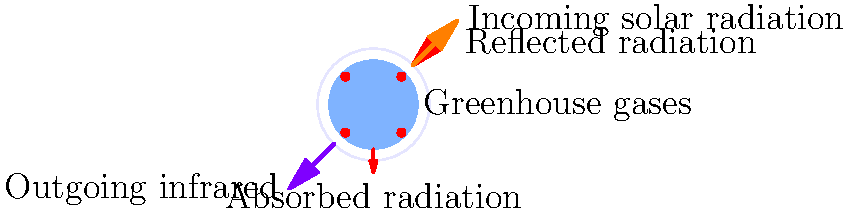As a politician advocating for climate change mitigation, you're presenting the greenhouse effect to your constituents. Using the diagram, explain how greenhouse gases contribute to global warming and why reducing emissions is crucial for preventing long-term environmental and economic impacts. 1. Solar radiation: The sun emits shortwave radiation that passes through the atmosphere and reaches Earth's surface.

2. Absorption and reflection: Some of this radiation is reflected back into space by clouds and Earth's surface, while the rest is absorbed by the planet.

3. Earth's emission: The absorbed energy warms the Earth, which then emits longwave infrared radiation back towards space.

4. Greenhouse gases: CO₂, methane, and other greenhouse gases in the atmosphere absorb some of this outgoing infrared radiation.

5. Heat trapping: These gases re-emit the absorbed energy in all directions, including back towards Earth's surface, effectively trapping heat in the lower atmosphere.

6. Enhanced greenhouse effect: As we increase greenhouse gas concentrations through human activities, more heat is trapped, leading to global warming.

7. Climate impacts: This warming causes various environmental changes, including sea-level rise, extreme weather events, and ecosystem disruptions.

8. Economic consequences: These changes can lead to significant economic impacts, affecting agriculture, infrastructure, and public health.

9. Mitigation importance: Reducing greenhouse gas emissions is crucial to slow down this process and minimize long-term environmental and economic damage.

10. Policy implications: As policymakers, we must implement strategies to reduce emissions, such as promoting renewable energy, improving energy efficiency, and supporting sustainable practices across industries.
Answer: Greenhouse gases trap outgoing infrared radiation, causing global warming. Reducing emissions is crucial to mitigate long-term environmental and economic impacts. 